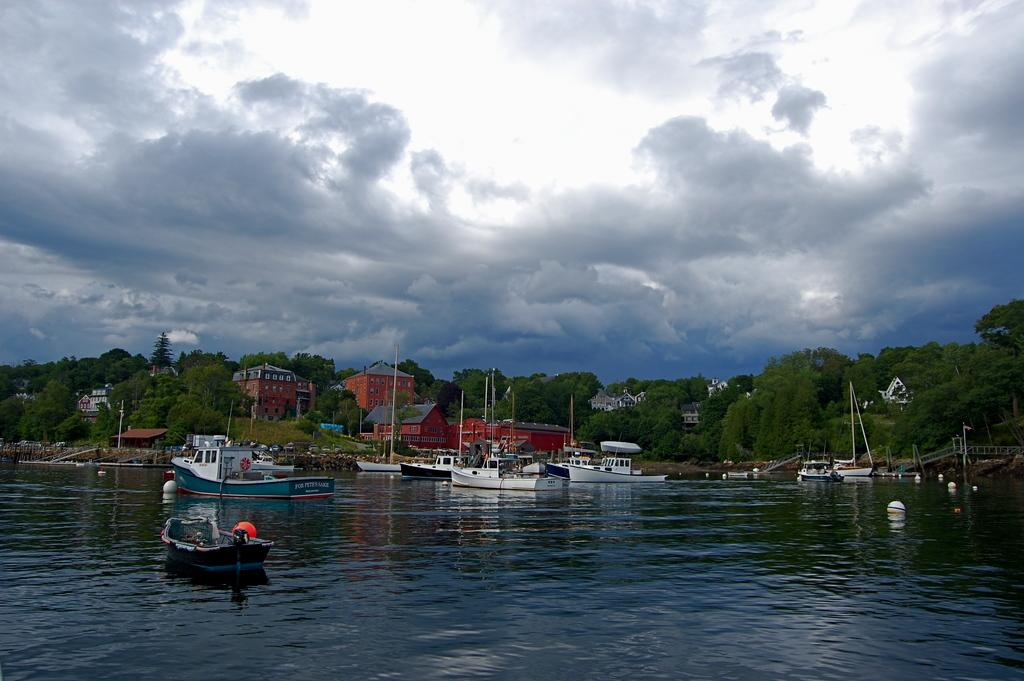What is in the water in the image? There are boats in the water in the image. What type of natural elements can be seen in the image? There are trees visible in the image. What type of man-made structures can be seen in the image? There are buildings in the image. What connects the two sides of the water in the image? There is a bridge in the image. What is the condition of the sky in the image? The sky is cloudy in the image. How much debt is owed by the boats in the image? There is no information about debt in the image, as it features boats in the water, trees, buildings, a bridge, and a cloudy sky. Can you tell me the distance between the airplane and the bridge in the image? There is no airplane present in the image, so it is not possible to determine the distance between it and the bridge. 